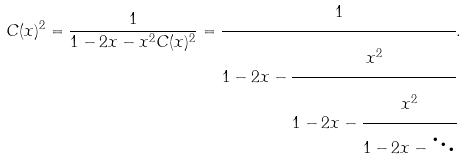<formula> <loc_0><loc_0><loc_500><loc_500>C ( x ) ^ { 2 } = \frac { 1 } { 1 - 2 x - x ^ { 2 } C ( x ) ^ { 2 } } = \cfrac { 1 } { 1 - 2 x - \cfrac { x ^ { 2 } } { 1 - 2 x - \cfrac { x ^ { 2 } } { 1 - 2 x - \ddots } } } .</formula> 